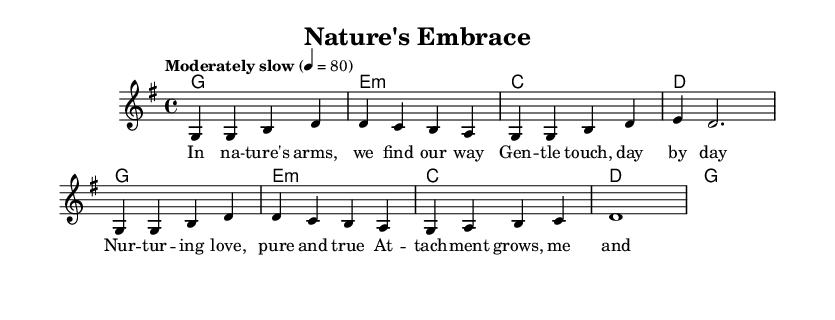What is the key signature of this music? The key signature is G major, indicated by one sharp (F#) at the beginning of the staff.
Answer: G major What is the time signature of the piece? The time signature is 4/4, meaning there are four beats in each measure and a quarter note receives one beat.
Answer: 4/4 What is the tempo marking for the music? The tempo marking is "Moderately slow" with a metronome marking of 80, indicating the speed of the piece.
Answer: Moderately slow How many measures are in the melody section? There are eight measures in the melody section as represented by the distinct groups of notes separated by vertical lines on the staff.
Answer: Eight Which chord is played on the first measure? The first measure features a G major chord, indicated by the chord symbol written above the staff.
Answer: G What is the emotional theme reflected in the lyrics? The lyrics convey themes of nurturing and attachment, celebrating love and connection between parents and children in a natural setting.
Answer: Nurturing and attachment How many lines of lyrics are in the verse? There are four lines of lyrics in the verse, displayed distinctly above the melody notes on the sheet music.
Answer: Four 